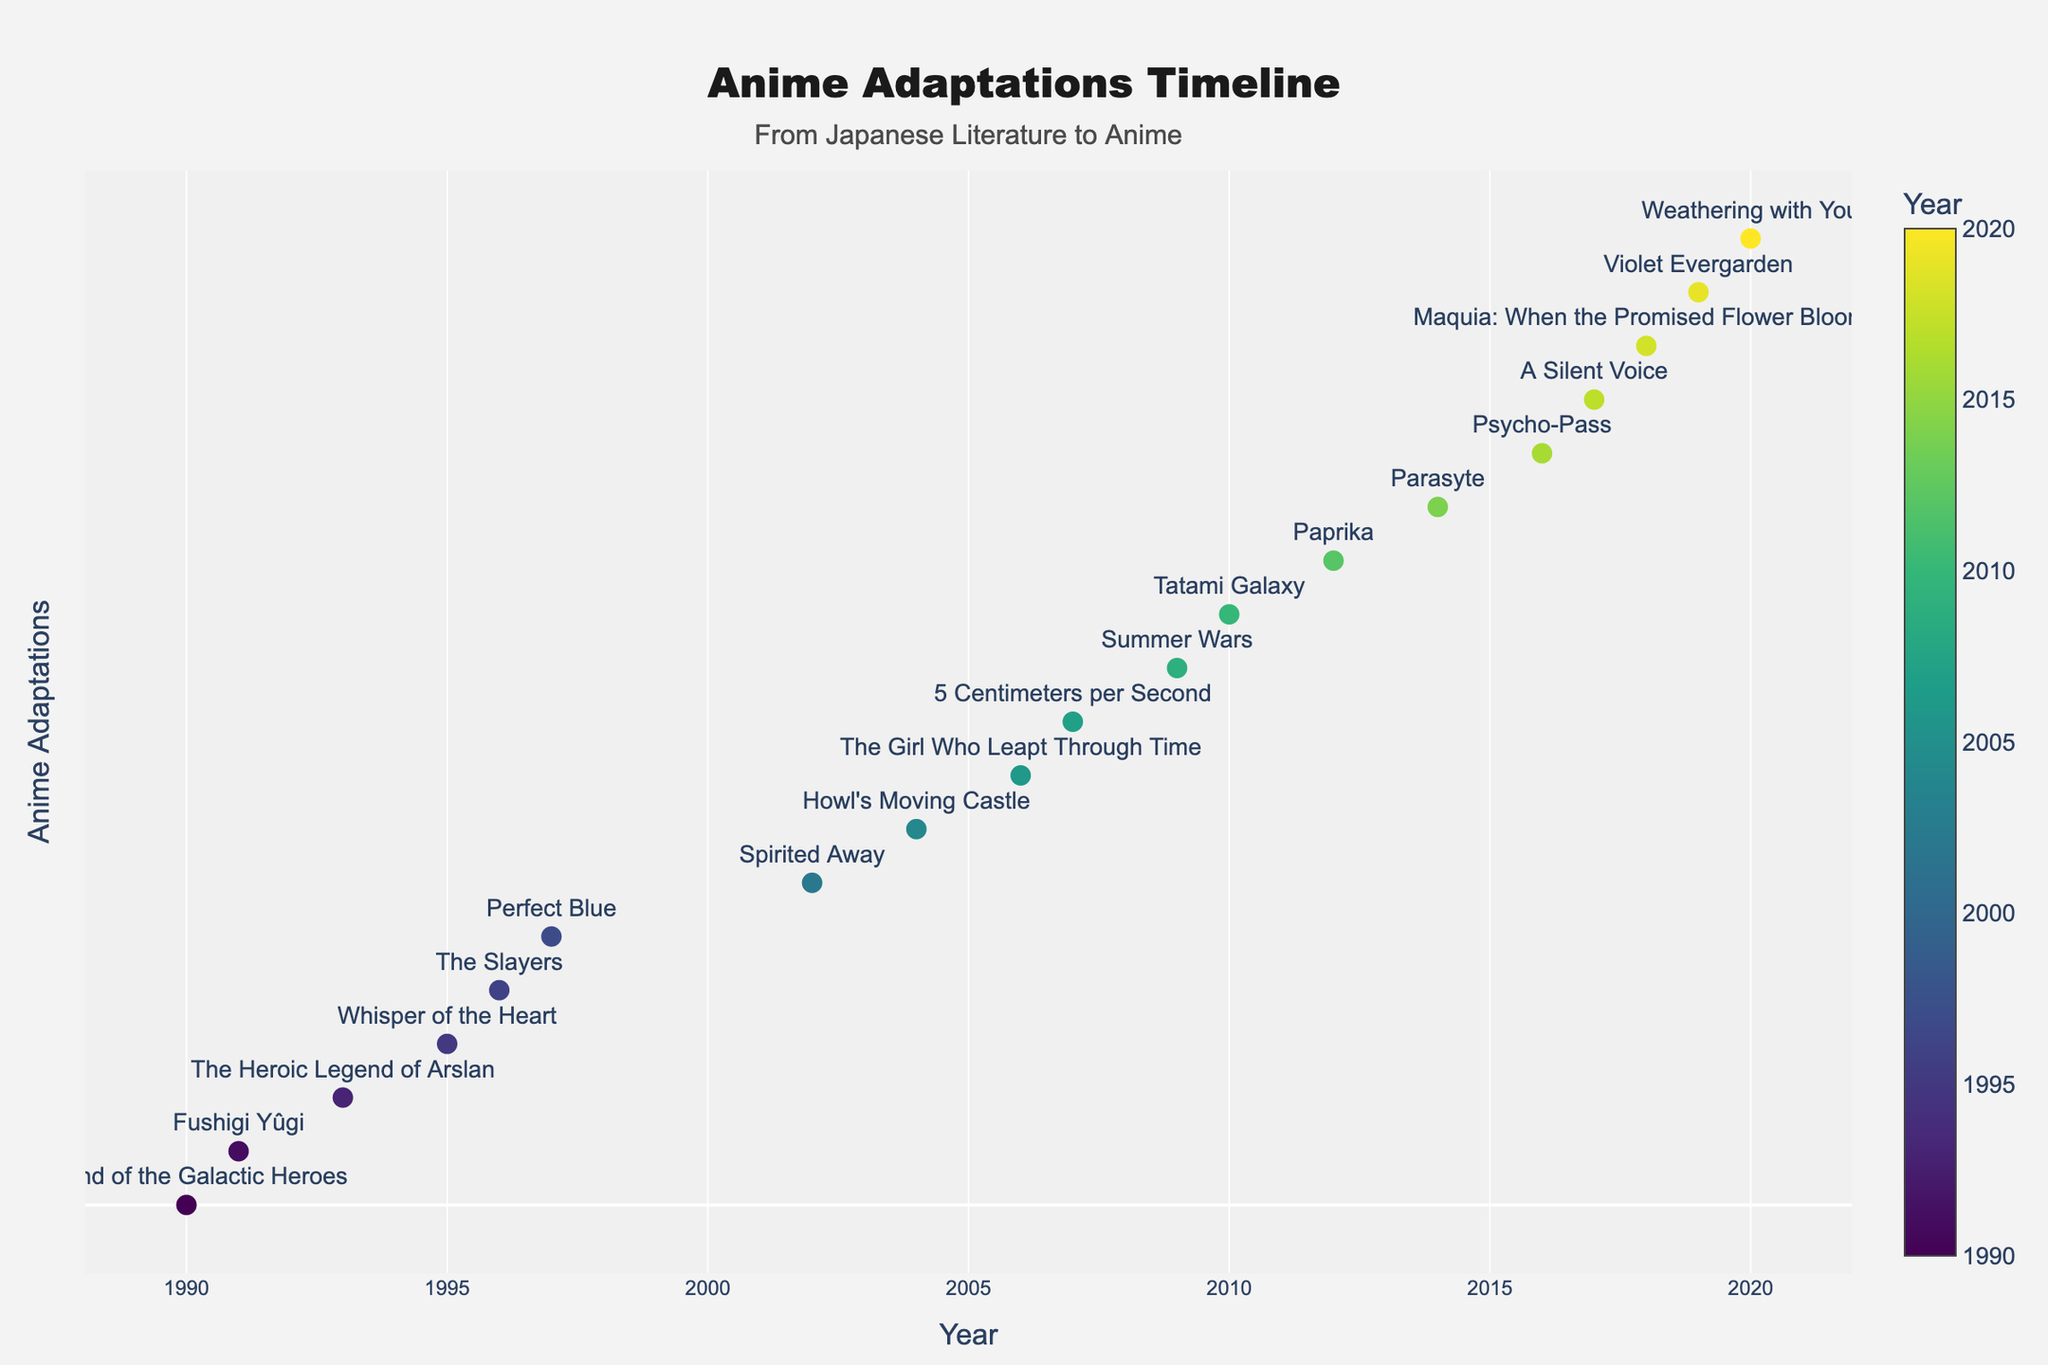what is the title of the plot? The title of the plot is displayed at the top and center of the figure. It usually describes what the plot is about.
Answer: Anime Adaptations Timeline Which anime adaptations were released in 2006? To find the anime adaptations released in 2006, look for the markers that align with the year 2006 on the x-axis. The associated labels will give you the anime titles.
Answer: The Girl Who Leapt Through Time What is the exact year span shown in the plot? The year span is determined by looking at the minimum and maximum values on the x-axis.
Answer: 1990 to 2020 How many anime adaptations were released after 2010? To count the number of anime adaptations released after 2010, identify the markers to the right of 2010 on the x-axis and count them.
Answer: 9 Which anime adaptation was based on a novel by Miyazaki Hayao? Hovering over the markers will show the details about the anime, novel, and author. Find the marker with Miyazaki Hayao as the author.
Answer: Spirited Away Identify the anime adaptation released in 1996 along with the author of its original novel. Find the marker on the x-axis corresponding to 1996 and read the label for the anime title. Hover over the marker to get the author's name.
Answer: The Slayers, Hajime Kanzaka What is the most recent novel adaptation in the plot? The most recent novel adaptation can be found by identifying the marker corresponding to the latest year on the x-axis.
Answer: Weathering with You Compare the number of anime adaptations between 2000-2009 and 2010-2020. Which period had more adaptations? Count the markers between 2000-2009 and 2010-2020 on the x-axis to compare the numbers.
Answer: 2010-2020 Which decade had the highest number of anime adaptations? By looking at the distribution of markers on the x-axis, count the number of markers per decade (1990-1999, 2000-2009, 2010-2020) to determine the highest frequency.
Answer: 2010-2020 Identify the anime adaptations by Yasutaka Tsutsui and their release years. Hover over the markers to find the author Yasutaka Tsutsui and note the corresponding titles and years on the x-axis.
Answer: The Girl Who Leapt Through Time (2006), Paprika (2012) 